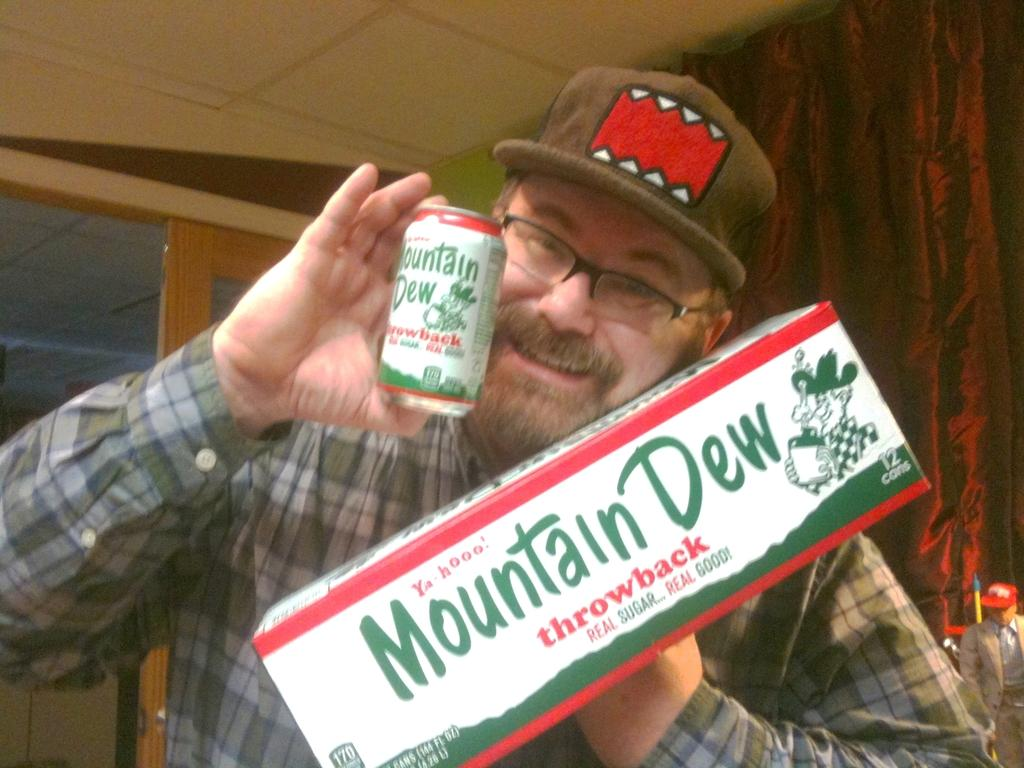What is the man in the image holding? The man is holding a box and a tin. Can you describe the person in the background of the image? There is a person in the background of the image, but no specific details are provided. What can be seen in the background of the image? There is a door and a ceiling in the background of the image. What type of ink is the man using to write on the foot in the image? There is no foot or ink present in the image; the man is holding a box and a tin. 